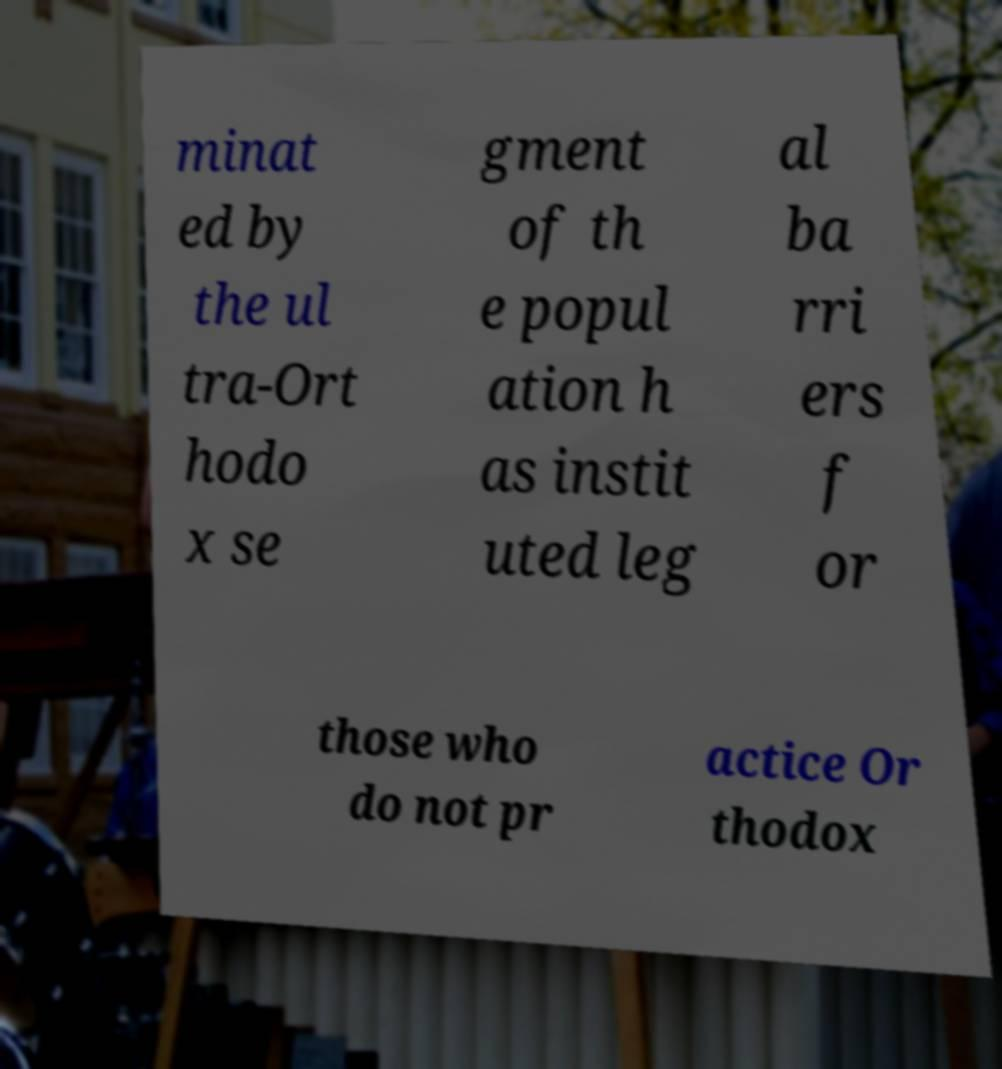Can you accurately transcribe the text from the provided image for me? minat ed by the ul tra-Ort hodo x se gment of th e popul ation h as instit uted leg al ba rri ers f or those who do not pr actice Or thodox 